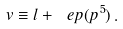Convert formula to latex. <formula><loc_0><loc_0><loc_500><loc_500>v \equiv l + \ e p ( p ^ { 5 } ) \, .</formula> 